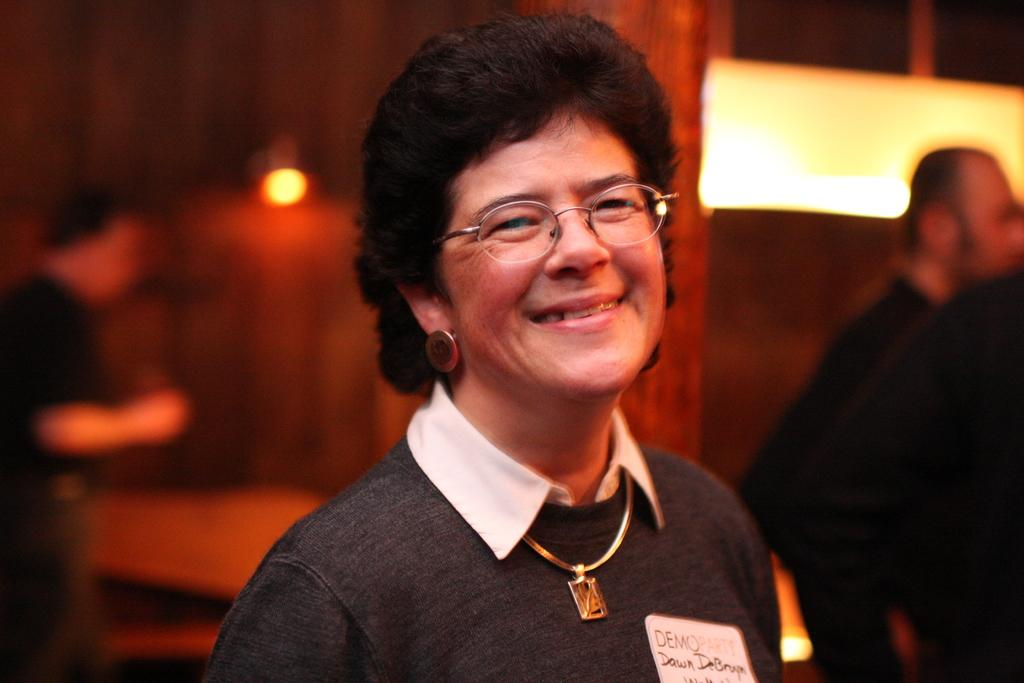Who is in the image? There is a person in the image. What is the person doing? The person is smiling. Can you describe the background of the image? The background of the image is blurry. Are there any other people visible in the image? Yes, there are people visible in the background. What else can be seen in the background of the image? There are lights visible in the background. What type of flower is the person holding in the image? There is no flower present in the image; the person is not holding anything. 